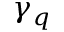<formula> <loc_0><loc_0><loc_500><loc_500>\gamma _ { q }</formula> 